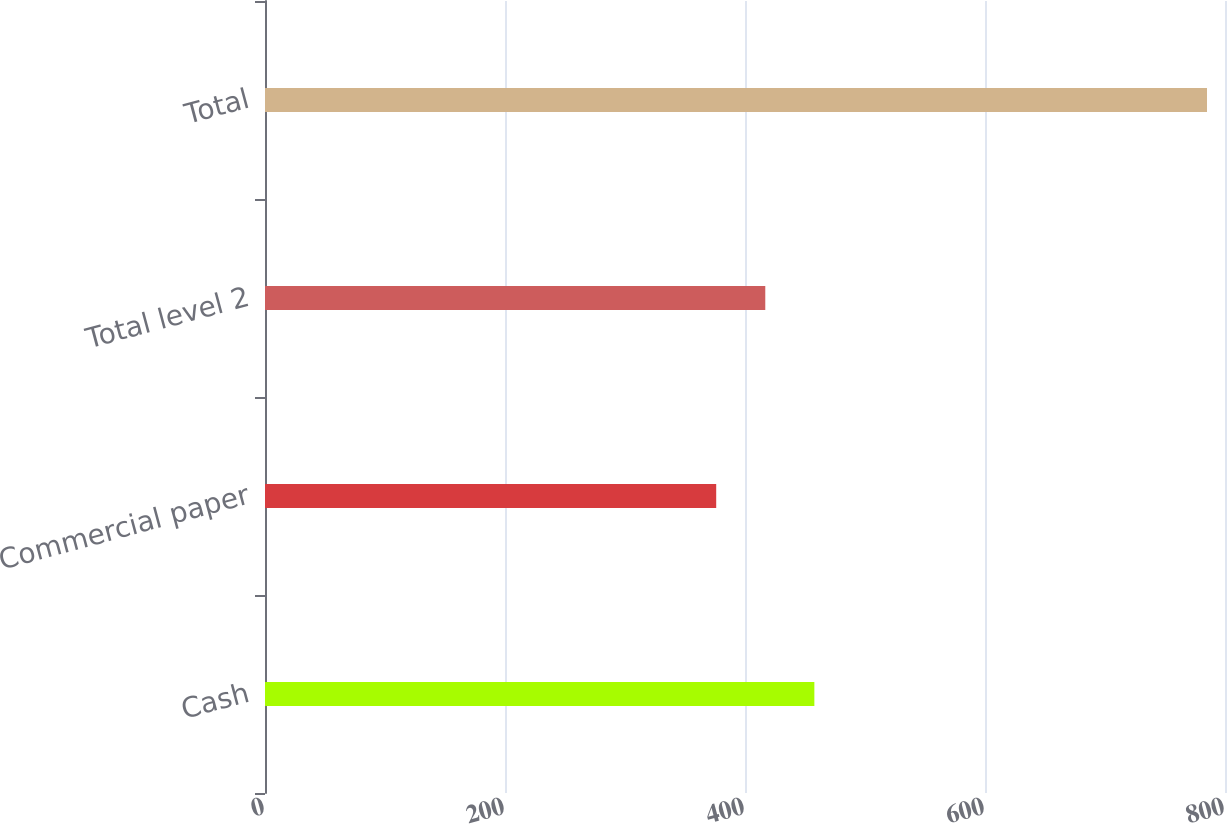Convert chart to OTSL. <chart><loc_0><loc_0><loc_500><loc_500><bar_chart><fcel>Cash<fcel>Commercial paper<fcel>Total level 2<fcel>Total<nl><fcel>457.8<fcel>376<fcel>416.9<fcel>785<nl></chart> 